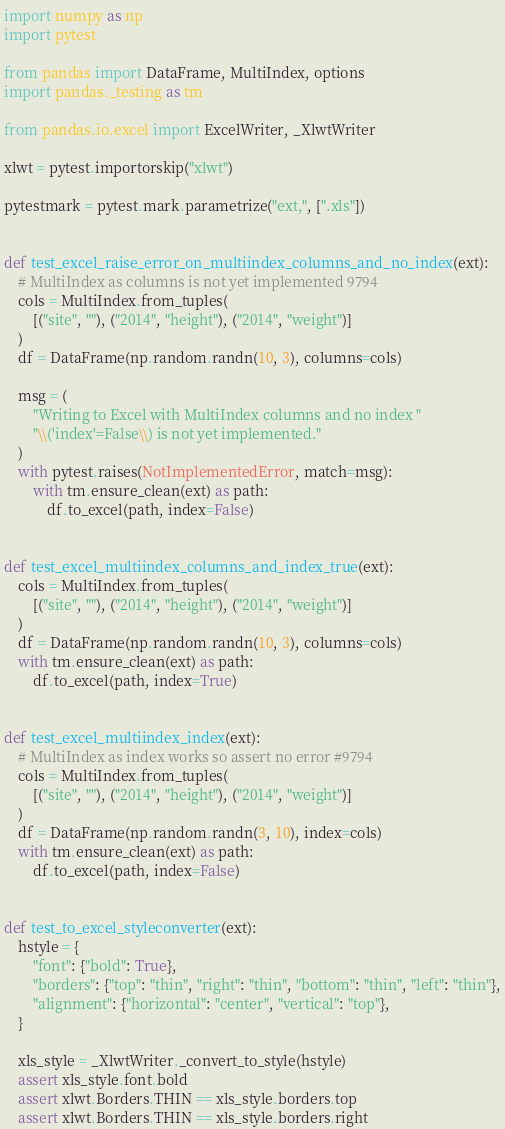<code> <loc_0><loc_0><loc_500><loc_500><_Python_>import numpy as np
import pytest

from pandas import DataFrame, MultiIndex, options
import pandas._testing as tm

from pandas.io.excel import ExcelWriter, _XlwtWriter

xlwt = pytest.importorskip("xlwt")

pytestmark = pytest.mark.parametrize("ext,", [".xls"])


def test_excel_raise_error_on_multiindex_columns_and_no_index(ext):
    # MultiIndex as columns is not yet implemented 9794
    cols = MultiIndex.from_tuples(
        [("site", ""), ("2014", "height"), ("2014", "weight")]
    )
    df = DataFrame(np.random.randn(10, 3), columns=cols)

    msg = (
        "Writing to Excel with MultiIndex columns and no index "
        "\\('index'=False\\) is not yet implemented."
    )
    with pytest.raises(NotImplementedError, match=msg):
        with tm.ensure_clean(ext) as path:
            df.to_excel(path, index=False)


def test_excel_multiindex_columns_and_index_true(ext):
    cols = MultiIndex.from_tuples(
        [("site", ""), ("2014", "height"), ("2014", "weight")]
    )
    df = DataFrame(np.random.randn(10, 3), columns=cols)
    with tm.ensure_clean(ext) as path:
        df.to_excel(path, index=True)


def test_excel_multiindex_index(ext):
    # MultiIndex as index works so assert no error #9794
    cols = MultiIndex.from_tuples(
        [("site", ""), ("2014", "height"), ("2014", "weight")]
    )
    df = DataFrame(np.random.randn(3, 10), index=cols)
    with tm.ensure_clean(ext) as path:
        df.to_excel(path, index=False)


def test_to_excel_styleconverter(ext):
    hstyle = {
        "font": {"bold": True},
        "borders": {"top": "thin", "right": "thin", "bottom": "thin", "left": "thin"},
        "alignment": {"horizontal": "center", "vertical": "top"},
    }

    xls_style = _XlwtWriter._convert_to_style(hstyle)
    assert xls_style.font.bold
    assert xlwt.Borders.THIN == xls_style.borders.top
    assert xlwt.Borders.THIN == xls_style.borders.right</code> 